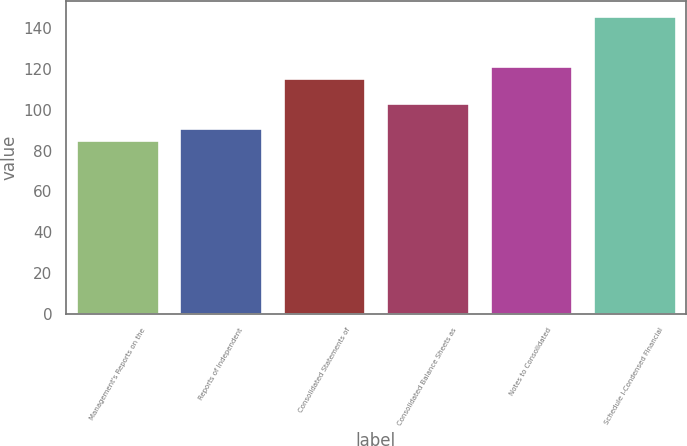Convert chart. <chart><loc_0><loc_0><loc_500><loc_500><bar_chart><fcel>Management's Reports on the<fcel>Reports of Independent<fcel>Consolidated Statements of<fcel>Consolidated Balance Sheets as<fcel>Notes to Consolidated<fcel>Schedule I-Condensed Financial<nl><fcel>85<fcel>91.1<fcel>115.5<fcel>103.3<fcel>121.6<fcel>146<nl></chart> 